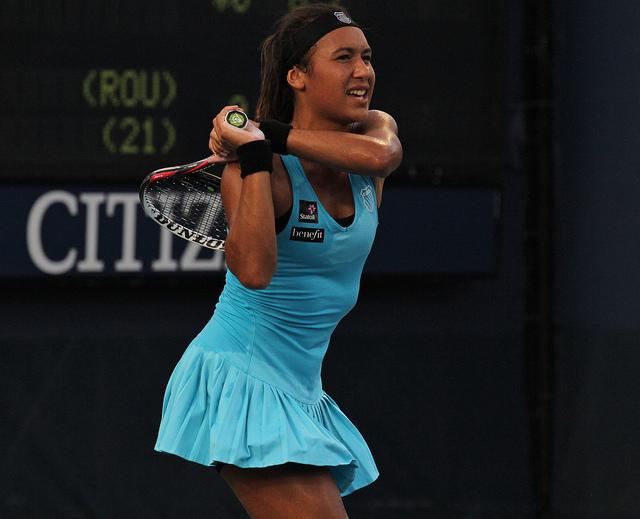Is this dress pink?
Keep it brief. No. What color is her hair?
Short answer required. Brown. What color dress is she wearing?
Keep it brief. Blue. Who is a sponsor of this event?
Quick response, please. Citizen. Is the woman with the racket wearing a pink shirt?
Concise answer only. No. Is this woman wearing long pants?
Write a very short answer. No. Is she strong?
Be succinct. Yes. What sport is she playing?
Concise answer only. Tennis. What color is her shirt?
Answer briefly. Blue. 